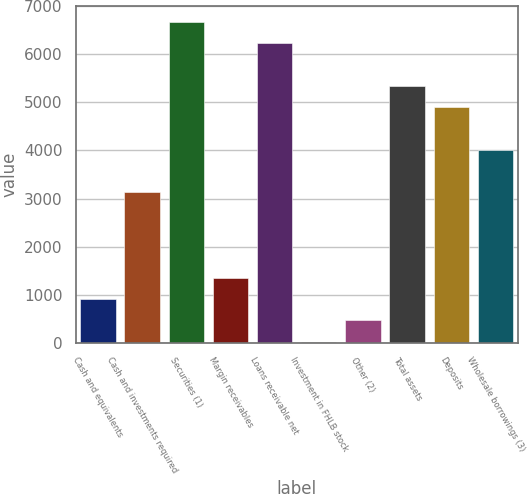<chart> <loc_0><loc_0><loc_500><loc_500><bar_chart><fcel>Cash and equivalents<fcel>Cash and investments required<fcel>Securities (1)<fcel>Margin receivables<fcel>Loans receivable net<fcel>Investment in FHLB stock<fcel>Other (2)<fcel>Total assets<fcel>Deposits<fcel>Wholesale borrowings (3)<nl><fcel>910.32<fcel>3125.62<fcel>6670.1<fcel>1353.38<fcel>6227.04<fcel>24.2<fcel>467.26<fcel>5340.92<fcel>4897.86<fcel>4011.74<nl></chart> 